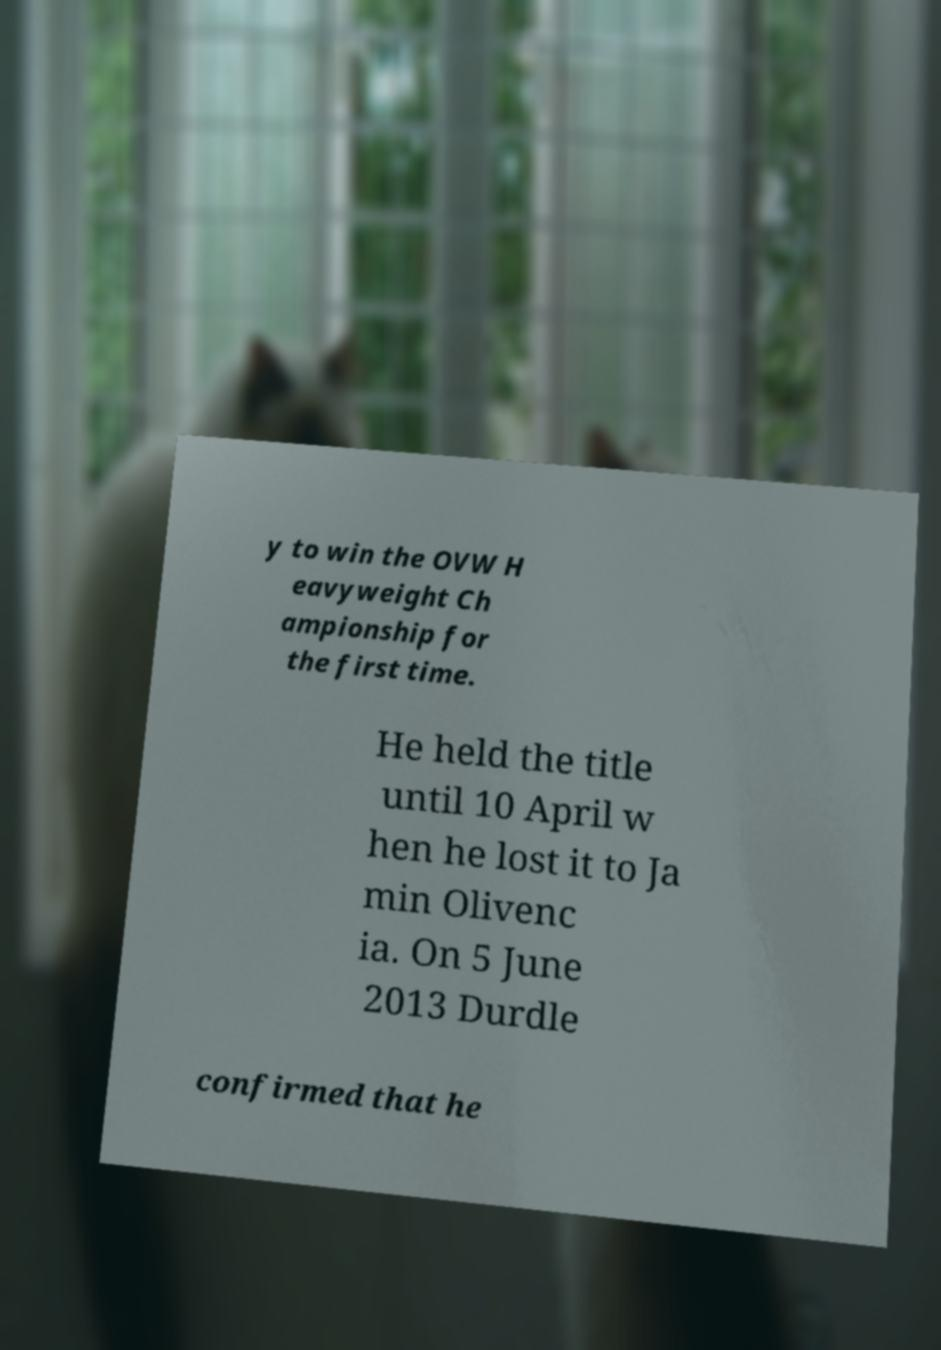Please read and relay the text visible in this image. What does it say? y to win the OVW H eavyweight Ch ampionship for the first time. He held the title until 10 April w hen he lost it to Ja min Olivenc ia. On 5 June 2013 Durdle confirmed that he 